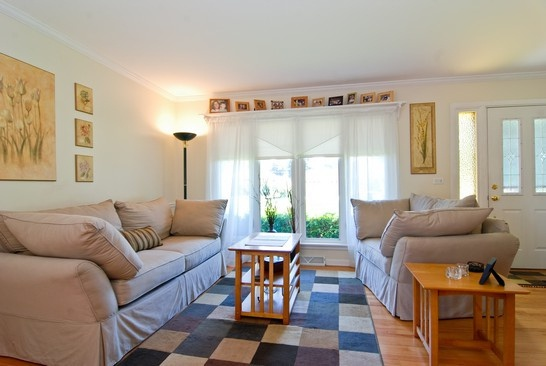Describe the objects in this image and their specific colors. I can see couch in darkgray and gray tones, couch in darkgray, gray, and maroon tones, vase in darkgray, black, teal, and navy tones, and vase in darkgray, black, gray, and purple tones in this image. 